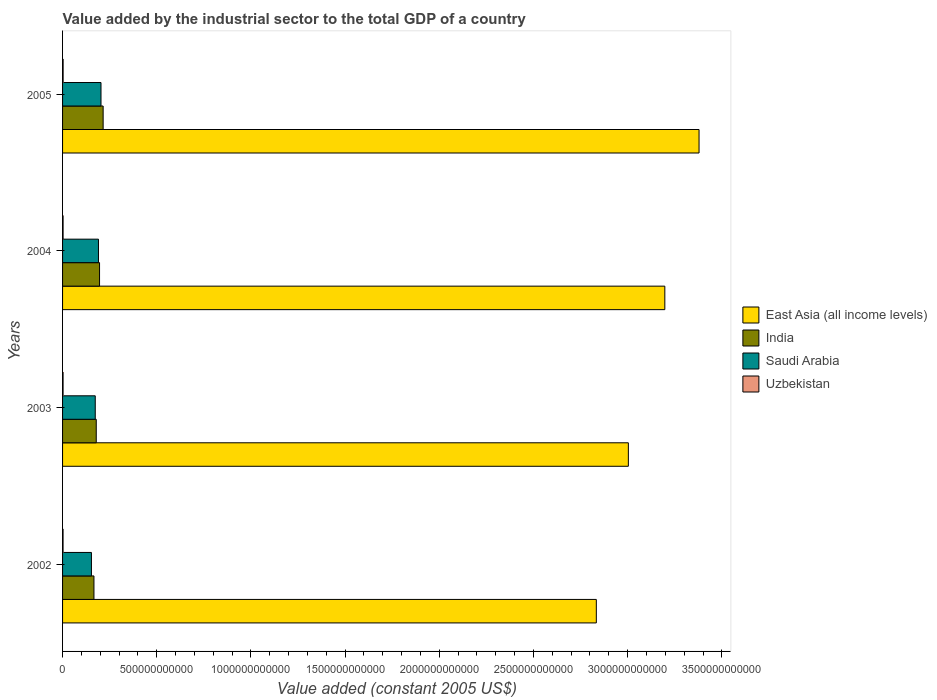Are the number of bars on each tick of the Y-axis equal?
Your answer should be compact. Yes. How many bars are there on the 3rd tick from the top?
Your answer should be very brief. 4. How many bars are there on the 3rd tick from the bottom?
Offer a terse response. 4. What is the value added by the industrial sector in India in 2004?
Provide a short and direct response. 1.96e+11. Across all years, what is the maximum value added by the industrial sector in India?
Give a very brief answer. 2.15e+11. Across all years, what is the minimum value added by the industrial sector in Saudi Arabia?
Make the answer very short. 1.53e+11. In which year was the value added by the industrial sector in Saudi Arabia maximum?
Keep it short and to the point. 2005. What is the total value added by the industrial sector in India in the graph?
Make the answer very short. 7.57e+11. What is the difference between the value added by the industrial sector in India in 2004 and that in 2005?
Your answer should be compact. -1.91e+1. What is the difference between the value added by the industrial sector in India in 2005 and the value added by the industrial sector in Uzbekistan in 2002?
Make the answer very short. 2.13e+11. What is the average value added by the industrial sector in Saudi Arabia per year?
Provide a succinct answer. 1.80e+11. In the year 2003, what is the difference between the value added by the industrial sector in India and value added by the industrial sector in East Asia (all income levels)?
Provide a succinct answer. -2.82e+12. What is the ratio of the value added by the industrial sector in Uzbekistan in 2003 to that in 2004?
Provide a short and direct response. 0.95. Is the value added by the industrial sector in Saudi Arabia in 2002 less than that in 2005?
Your answer should be compact. Yes. Is the difference between the value added by the industrial sector in India in 2002 and 2004 greater than the difference between the value added by the industrial sector in East Asia (all income levels) in 2002 and 2004?
Make the answer very short. Yes. What is the difference between the highest and the second highest value added by the industrial sector in Uzbekistan?
Your response must be concise. 1.40e+08. What is the difference between the highest and the lowest value added by the industrial sector in Saudi Arabia?
Keep it short and to the point. 5.07e+1. In how many years, is the value added by the industrial sector in India greater than the average value added by the industrial sector in India taken over all years?
Provide a succinct answer. 2. Is the sum of the value added by the industrial sector in Saudi Arabia in 2003 and 2005 greater than the maximum value added by the industrial sector in India across all years?
Your answer should be compact. Yes. Is it the case that in every year, the sum of the value added by the industrial sector in India and value added by the industrial sector in East Asia (all income levels) is greater than the sum of value added by the industrial sector in Saudi Arabia and value added by the industrial sector in Uzbekistan?
Ensure brevity in your answer.  No. What does the 4th bar from the top in 2004 represents?
Your response must be concise. East Asia (all income levels). What does the 2nd bar from the bottom in 2003 represents?
Your answer should be very brief. India. Are all the bars in the graph horizontal?
Offer a terse response. Yes. How many years are there in the graph?
Provide a succinct answer. 4. What is the difference between two consecutive major ticks on the X-axis?
Your answer should be compact. 5.00e+11. Are the values on the major ticks of X-axis written in scientific E-notation?
Give a very brief answer. No. Does the graph contain any zero values?
Give a very brief answer. No. Where does the legend appear in the graph?
Provide a short and direct response. Center right. What is the title of the graph?
Make the answer very short. Value added by the industrial sector to the total GDP of a country. What is the label or title of the X-axis?
Offer a terse response. Value added (constant 2005 US$). What is the label or title of the Y-axis?
Offer a very short reply. Years. What is the Value added (constant 2005 US$) of East Asia (all income levels) in 2002?
Your response must be concise. 2.83e+12. What is the Value added (constant 2005 US$) in India in 2002?
Make the answer very short. 1.67e+11. What is the Value added (constant 2005 US$) in Saudi Arabia in 2002?
Your answer should be compact. 1.53e+11. What is the Value added (constant 2005 US$) in Uzbekistan in 2002?
Offer a very short reply. 2.60e+09. What is the Value added (constant 2005 US$) in East Asia (all income levels) in 2003?
Ensure brevity in your answer.  3.00e+12. What is the Value added (constant 2005 US$) of India in 2003?
Provide a succinct answer. 1.79e+11. What is the Value added (constant 2005 US$) in Saudi Arabia in 2003?
Your answer should be compact. 1.74e+11. What is the Value added (constant 2005 US$) of Uzbekistan in 2003?
Keep it short and to the point. 2.69e+09. What is the Value added (constant 2005 US$) in East Asia (all income levels) in 2004?
Ensure brevity in your answer.  3.20e+12. What is the Value added (constant 2005 US$) of India in 2004?
Provide a succinct answer. 1.96e+11. What is the Value added (constant 2005 US$) of Saudi Arabia in 2004?
Give a very brief answer. 1.91e+11. What is the Value added (constant 2005 US$) in Uzbekistan in 2004?
Offer a terse response. 2.82e+09. What is the Value added (constant 2005 US$) in East Asia (all income levels) in 2005?
Offer a very short reply. 3.38e+12. What is the Value added (constant 2005 US$) of India in 2005?
Provide a succinct answer. 2.15e+11. What is the Value added (constant 2005 US$) of Saudi Arabia in 2005?
Your answer should be very brief. 2.04e+11. What is the Value added (constant 2005 US$) in Uzbekistan in 2005?
Provide a succinct answer. 2.96e+09. Across all years, what is the maximum Value added (constant 2005 US$) in East Asia (all income levels)?
Your answer should be compact. 3.38e+12. Across all years, what is the maximum Value added (constant 2005 US$) in India?
Your answer should be very brief. 2.15e+11. Across all years, what is the maximum Value added (constant 2005 US$) in Saudi Arabia?
Give a very brief answer. 2.04e+11. Across all years, what is the maximum Value added (constant 2005 US$) in Uzbekistan?
Your answer should be compact. 2.96e+09. Across all years, what is the minimum Value added (constant 2005 US$) of East Asia (all income levels)?
Give a very brief answer. 2.83e+12. Across all years, what is the minimum Value added (constant 2005 US$) of India?
Your answer should be very brief. 1.67e+11. Across all years, what is the minimum Value added (constant 2005 US$) in Saudi Arabia?
Keep it short and to the point. 1.53e+11. Across all years, what is the minimum Value added (constant 2005 US$) in Uzbekistan?
Provide a short and direct response. 2.60e+09. What is the total Value added (constant 2005 US$) in East Asia (all income levels) in the graph?
Provide a short and direct response. 1.24e+13. What is the total Value added (constant 2005 US$) in India in the graph?
Offer a very short reply. 7.57e+11. What is the total Value added (constant 2005 US$) of Saudi Arabia in the graph?
Offer a terse response. 7.21e+11. What is the total Value added (constant 2005 US$) in Uzbekistan in the graph?
Your answer should be compact. 1.11e+1. What is the difference between the Value added (constant 2005 US$) in East Asia (all income levels) in 2002 and that in 2003?
Ensure brevity in your answer.  -1.70e+11. What is the difference between the Value added (constant 2005 US$) in India in 2002 and that in 2003?
Provide a short and direct response. -1.22e+1. What is the difference between the Value added (constant 2005 US$) of Saudi Arabia in 2002 and that in 2003?
Ensure brevity in your answer.  -2.03e+1. What is the difference between the Value added (constant 2005 US$) of Uzbekistan in 2002 and that in 2003?
Make the answer very short. -8.27e+07. What is the difference between the Value added (constant 2005 US$) of East Asia (all income levels) in 2002 and that in 2004?
Keep it short and to the point. -3.64e+11. What is the difference between the Value added (constant 2005 US$) in India in 2002 and that in 2004?
Offer a terse response. -2.97e+1. What is the difference between the Value added (constant 2005 US$) in Saudi Arabia in 2002 and that in 2004?
Your answer should be very brief. -3.73e+1. What is the difference between the Value added (constant 2005 US$) in Uzbekistan in 2002 and that in 2004?
Offer a very short reply. -2.17e+08. What is the difference between the Value added (constant 2005 US$) of East Asia (all income levels) in 2002 and that in 2005?
Keep it short and to the point. -5.45e+11. What is the difference between the Value added (constant 2005 US$) of India in 2002 and that in 2005?
Make the answer very short. -4.88e+1. What is the difference between the Value added (constant 2005 US$) in Saudi Arabia in 2002 and that in 2005?
Offer a terse response. -5.07e+1. What is the difference between the Value added (constant 2005 US$) of Uzbekistan in 2002 and that in 2005?
Offer a very short reply. -3.57e+08. What is the difference between the Value added (constant 2005 US$) of East Asia (all income levels) in 2003 and that in 2004?
Provide a short and direct response. -1.94e+11. What is the difference between the Value added (constant 2005 US$) in India in 2003 and that in 2004?
Provide a short and direct response. -1.75e+1. What is the difference between the Value added (constant 2005 US$) of Saudi Arabia in 2003 and that in 2004?
Your answer should be compact. -1.70e+1. What is the difference between the Value added (constant 2005 US$) of Uzbekistan in 2003 and that in 2004?
Provide a succinct answer. -1.34e+08. What is the difference between the Value added (constant 2005 US$) of East Asia (all income levels) in 2003 and that in 2005?
Provide a short and direct response. -3.75e+11. What is the difference between the Value added (constant 2005 US$) in India in 2003 and that in 2005?
Ensure brevity in your answer.  -3.66e+1. What is the difference between the Value added (constant 2005 US$) in Saudi Arabia in 2003 and that in 2005?
Your answer should be compact. -3.05e+1. What is the difference between the Value added (constant 2005 US$) of Uzbekistan in 2003 and that in 2005?
Your answer should be compact. -2.75e+08. What is the difference between the Value added (constant 2005 US$) of East Asia (all income levels) in 2004 and that in 2005?
Offer a terse response. -1.82e+11. What is the difference between the Value added (constant 2005 US$) of India in 2004 and that in 2005?
Offer a very short reply. -1.91e+1. What is the difference between the Value added (constant 2005 US$) of Saudi Arabia in 2004 and that in 2005?
Your response must be concise. -1.34e+1. What is the difference between the Value added (constant 2005 US$) of Uzbekistan in 2004 and that in 2005?
Your answer should be compact. -1.40e+08. What is the difference between the Value added (constant 2005 US$) of East Asia (all income levels) in 2002 and the Value added (constant 2005 US$) of India in 2003?
Offer a terse response. 2.65e+12. What is the difference between the Value added (constant 2005 US$) of East Asia (all income levels) in 2002 and the Value added (constant 2005 US$) of Saudi Arabia in 2003?
Make the answer very short. 2.66e+12. What is the difference between the Value added (constant 2005 US$) of East Asia (all income levels) in 2002 and the Value added (constant 2005 US$) of Uzbekistan in 2003?
Offer a very short reply. 2.83e+12. What is the difference between the Value added (constant 2005 US$) in India in 2002 and the Value added (constant 2005 US$) in Saudi Arabia in 2003?
Offer a terse response. -6.93e+09. What is the difference between the Value added (constant 2005 US$) in India in 2002 and the Value added (constant 2005 US$) in Uzbekistan in 2003?
Keep it short and to the point. 1.64e+11. What is the difference between the Value added (constant 2005 US$) of Saudi Arabia in 2002 and the Value added (constant 2005 US$) of Uzbekistan in 2003?
Keep it short and to the point. 1.51e+11. What is the difference between the Value added (constant 2005 US$) of East Asia (all income levels) in 2002 and the Value added (constant 2005 US$) of India in 2004?
Offer a very short reply. 2.64e+12. What is the difference between the Value added (constant 2005 US$) of East Asia (all income levels) in 2002 and the Value added (constant 2005 US$) of Saudi Arabia in 2004?
Offer a very short reply. 2.64e+12. What is the difference between the Value added (constant 2005 US$) of East Asia (all income levels) in 2002 and the Value added (constant 2005 US$) of Uzbekistan in 2004?
Your response must be concise. 2.83e+12. What is the difference between the Value added (constant 2005 US$) of India in 2002 and the Value added (constant 2005 US$) of Saudi Arabia in 2004?
Ensure brevity in your answer.  -2.39e+1. What is the difference between the Value added (constant 2005 US$) of India in 2002 and the Value added (constant 2005 US$) of Uzbekistan in 2004?
Keep it short and to the point. 1.64e+11. What is the difference between the Value added (constant 2005 US$) in Saudi Arabia in 2002 and the Value added (constant 2005 US$) in Uzbekistan in 2004?
Provide a succinct answer. 1.50e+11. What is the difference between the Value added (constant 2005 US$) of East Asia (all income levels) in 2002 and the Value added (constant 2005 US$) of India in 2005?
Provide a short and direct response. 2.62e+12. What is the difference between the Value added (constant 2005 US$) in East Asia (all income levels) in 2002 and the Value added (constant 2005 US$) in Saudi Arabia in 2005?
Make the answer very short. 2.63e+12. What is the difference between the Value added (constant 2005 US$) in East Asia (all income levels) in 2002 and the Value added (constant 2005 US$) in Uzbekistan in 2005?
Your answer should be compact. 2.83e+12. What is the difference between the Value added (constant 2005 US$) in India in 2002 and the Value added (constant 2005 US$) in Saudi Arabia in 2005?
Keep it short and to the point. -3.74e+1. What is the difference between the Value added (constant 2005 US$) in India in 2002 and the Value added (constant 2005 US$) in Uzbekistan in 2005?
Your answer should be very brief. 1.64e+11. What is the difference between the Value added (constant 2005 US$) of Saudi Arabia in 2002 and the Value added (constant 2005 US$) of Uzbekistan in 2005?
Offer a terse response. 1.50e+11. What is the difference between the Value added (constant 2005 US$) in East Asia (all income levels) in 2003 and the Value added (constant 2005 US$) in India in 2004?
Make the answer very short. 2.81e+12. What is the difference between the Value added (constant 2005 US$) in East Asia (all income levels) in 2003 and the Value added (constant 2005 US$) in Saudi Arabia in 2004?
Your response must be concise. 2.81e+12. What is the difference between the Value added (constant 2005 US$) of East Asia (all income levels) in 2003 and the Value added (constant 2005 US$) of Uzbekistan in 2004?
Keep it short and to the point. 3.00e+12. What is the difference between the Value added (constant 2005 US$) in India in 2003 and the Value added (constant 2005 US$) in Saudi Arabia in 2004?
Your answer should be compact. -1.18e+1. What is the difference between the Value added (constant 2005 US$) of India in 2003 and the Value added (constant 2005 US$) of Uzbekistan in 2004?
Your answer should be very brief. 1.76e+11. What is the difference between the Value added (constant 2005 US$) in Saudi Arabia in 2003 and the Value added (constant 2005 US$) in Uzbekistan in 2004?
Provide a succinct answer. 1.71e+11. What is the difference between the Value added (constant 2005 US$) of East Asia (all income levels) in 2003 and the Value added (constant 2005 US$) of India in 2005?
Offer a very short reply. 2.79e+12. What is the difference between the Value added (constant 2005 US$) in East Asia (all income levels) in 2003 and the Value added (constant 2005 US$) in Saudi Arabia in 2005?
Your answer should be very brief. 2.80e+12. What is the difference between the Value added (constant 2005 US$) in East Asia (all income levels) in 2003 and the Value added (constant 2005 US$) in Uzbekistan in 2005?
Offer a terse response. 3.00e+12. What is the difference between the Value added (constant 2005 US$) of India in 2003 and the Value added (constant 2005 US$) of Saudi Arabia in 2005?
Give a very brief answer. -2.52e+1. What is the difference between the Value added (constant 2005 US$) in India in 2003 and the Value added (constant 2005 US$) in Uzbekistan in 2005?
Your response must be concise. 1.76e+11. What is the difference between the Value added (constant 2005 US$) of Saudi Arabia in 2003 and the Value added (constant 2005 US$) of Uzbekistan in 2005?
Make the answer very short. 1.71e+11. What is the difference between the Value added (constant 2005 US$) of East Asia (all income levels) in 2004 and the Value added (constant 2005 US$) of India in 2005?
Your answer should be compact. 2.98e+12. What is the difference between the Value added (constant 2005 US$) in East Asia (all income levels) in 2004 and the Value added (constant 2005 US$) in Saudi Arabia in 2005?
Provide a succinct answer. 2.99e+12. What is the difference between the Value added (constant 2005 US$) in East Asia (all income levels) in 2004 and the Value added (constant 2005 US$) in Uzbekistan in 2005?
Ensure brevity in your answer.  3.19e+12. What is the difference between the Value added (constant 2005 US$) in India in 2004 and the Value added (constant 2005 US$) in Saudi Arabia in 2005?
Your answer should be very brief. -7.65e+09. What is the difference between the Value added (constant 2005 US$) of India in 2004 and the Value added (constant 2005 US$) of Uzbekistan in 2005?
Offer a very short reply. 1.93e+11. What is the difference between the Value added (constant 2005 US$) in Saudi Arabia in 2004 and the Value added (constant 2005 US$) in Uzbekistan in 2005?
Give a very brief answer. 1.88e+11. What is the average Value added (constant 2005 US$) in East Asia (all income levels) per year?
Offer a terse response. 3.10e+12. What is the average Value added (constant 2005 US$) of India per year?
Ensure brevity in your answer.  1.89e+11. What is the average Value added (constant 2005 US$) of Saudi Arabia per year?
Keep it short and to the point. 1.80e+11. What is the average Value added (constant 2005 US$) of Uzbekistan per year?
Ensure brevity in your answer.  2.77e+09. In the year 2002, what is the difference between the Value added (constant 2005 US$) of East Asia (all income levels) and Value added (constant 2005 US$) of India?
Make the answer very short. 2.67e+12. In the year 2002, what is the difference between the Value added (constant 2005 US$) of East Asia (all income levels) and Value added (constant 2005 US$) of Saudi Arabia?
Provide a short and direct response. 2.68e+12. In the year 2002, what is the difference between the Value added (constant 2005 US$) in East Asia (all income levels) and Value added (constant 2005 US$) in Uzbekistan?
Keep it short and to the point. 2.83e+12. In the year 2002, what is the difference between the Value added (constant 2005 US$) in India and Value added (constant 2005 US$) in Saudi Arabia?
Give a very brief answer. 1.33e+1. In the year 2002, what is the difference between the Value added (constant 2005 US$) in India and Value added (constant 2005 US$) in Uzbekistan?
Your answer should be compact. 1.64e+11. In the year 2002, what is the difference between the Value added (constant 2005 US$) of Saudi Arabia and Value added (constant 2005 US$) of Uzbekistan?
Keep it short and to the point. 1.51e+11. In the year 2003, what is the difference between the Value added (constant 2005 US$) of East Asia (all income levels) and Value added (constant 2005 US$) of India?
Make the answer very short. 2.82e+12. In the year 2003, what is the difference between the Value added (constant 2005 US$) of East Asia (all income levels) and Value added (constant 2005 US$) of Saudi Arabia?
Your response must be concise. 2.83e+12. In the year 2003, what is the difference between the Value added (constant 2005 US$) of East Asia (all income levels) and Value added (constant 2005 US$) of Uzbekistan?
Your answer should be very brief. 3.00e+12. In the year 2003, what is the difference between the Value added (constant 2005 US$) of India and Value added (constant 2005 US$) of Saudi Arabia?
Give a very brief answer. 5.27e+09. In the year 2003, what is the difference between the Value added (constant 2005 US$) in India and Value added (constant 2005 US$) in Uzbekistan?
Offer a terse response. 1.76e+11. In the year 2003, what is the difference between the Value added (constant 2005 US$) in Saudi Arabia and Value added (constant 2005 US$) in Uzbekistan?
Offer a very short reply. 1.71e+11. In the year 2004, what is the difference between the Value added (constant 2005 US$) of East Asia (all income levels) and Value added (constant 2005 US$) of India?
Offer a terse response. 3.00e+12. In the year 2004, what is the difference between the Value added (constant 2005 US$) in East Asia (all income levels) and Value added (constant 2005 US$) in Saudi Arabia?
Make the answer very short. 3.01e+12. In the year 2004, what is the difference between the Value added (constant 2005 US$) of East Asia (all income levels) and Value added (constant 2005 US$) of Uzbekistan?
Offer a terse response. 3.19e+12. In the year 2004, what is the difference between the Value added (constant 2005 US$) in India and Value added (constant 2005 US$) in Saudi Arabia?
Ensure brevity in your answer.  5.80e+09. In the year 2004, what is the difference between the Value added (constant 2005 US$) of India and Value added (constant 2005 US$) of Uzbekistan?
Give a very brief answer. 1.94e+11. In the year 2004, what is the difference between the Value added (constant 2005 US$) of Saudi Arabia and Value added (constant 2005 US$) of Uzbekistan?
Your answer should be compact. 1.88e+11. In the year 2005, what is the difference between the Value added (constant 2005 US$) of East Asia (all income levels) and Value added (constant 2005 US$) of India?
Offer a terse response. 3.16e+12. In the year 2005, what is the difference between the Value added (constant 2005 US$) in East Asia (all income levels) and Value added (constant 2005 US$) in Saudi Arabia?
Your response must be concise. 3.17e+12. In the year 2005, what is the difference between the Value added (constant 2005 US$) in East Asia (all income levels) and Value added (constant 2005 US$) in Uzbekistan?
Make the answer very short. 3.38e+12. In the year 2005, what is the difference between the Value added (constant 2005 US$) of India and Value added (constant 2005 US$) of Saudi Arabia?
Give a very brief answer. 1.14e+1. In the year 2005, what is the difference between the Value added (constant 2005 US$) of India and Value added (constant 2005 US$) of Uzbekistan?
Provide a succinct answer. 2.12e+11. In the year 2005, what is the difference between the Value added (constant 2005 US$) in Saudi Arabia and Value added (constant 2005 US$) in Uzbekistan?
Provide a succinct answer. 2.01e+11. What is the ratio of the Value added (constant 2005 US$) in East Asia (all income levels) in 2002 to that in 2003?
Offer a terse response. 0.94. What is the ratio of the Value added (constant 2005 US$) in India in 2002 to that in 2003?
Your response must be concise. 0.93. What is the ratio of the Value added (constant 2005 US$) in Saudi Arabia in 2002 to that in 2003?
Your answer should be very brief. 0.88. What is the ratio of the Value added (constant 2005 US$) in Uzbekistan in 2002 to that in 2003?
Offer a terse response. 0.97. What is the ratio of the Value added (constant 2005 US$) in East Asia (all income levels) in 2002 to that in 2004?
Your answer should be very brief. 0.89. What is the ratio of the Value added (constant 2005 US$) of India in 2002 to that in 2004?
Give a very brief answer. 0.85. What is the ratio of the Value added (constant 2005 US$) in Saudi Arabia in 2002 to that in 2004?
Provide a short and direct response. 0.8. What is the ratio of the Value added (constant 2005 US$) in Uzbekistan in 2002 to that in 2004?
Provide a short and direct response. 0.92. What is the ratio of the Value added (constant 2005 US$) in East Asia (all income levels) in 2002 to that in 2005?
Your answer should be very brief. 0.84. What is the ratio of the Value added (constant 2005 US$) in India in 2002 to that in 2005?
Keep it short and to the point. 0.77. What is the ratio of the Value added (constant 2005 US$) in Saudi Arabia in 2002 to that in 2005?
Provide a succinct answer. 0.75. What is the ratio of the Value added (constant 2005 US$) in Uzbekistan in 2002 to that in 2005?
Your answer should be very brief. 0.88. What is the ratio of the Value added (constant 2005 US$) in East Asia (all income levels) in 2003 to that in 2004?
Ensure brevity in your answer.  0.94. What is the ratio of the Value added (constant 2005 US$) in India in 2003 to that in 2004?
Make the answer very short. 0.91. What is the ratio of the Value added (constant 2005 US$) in Saudi Arabia in 2003 to that in 2004?
Your answer should be compact. 0.91. What is the ratio of the Value added (constant 2005 US$) of Uzbekistan in 2003 to that in 2004?
Your answer should be very brief. 0.95. What is the ratio of the Value added (constant 2005 US$) in India in 2003 to that in 2005?
Your answer should be compact. 0.83. What is the ratio of the Value added (constant 2005 US$) in Saudi Arabia in 2003 to that in 2005?
Your response must be concise. 0.85. What is the ratio of the Value added (constant 2005 US$) of Uzbekistan in 2003 to that in 2005?
Your answer should be compact. 0.91. What is the ratio of the Value added (constant 2005 US$) of East Asia (all income levels) in 2004 to that in 2005?
Provide a succinct answer. 0.95. What is the ratio of the Value added (constant 2005 US$) of India in 2004 to that in 2005?
Provide a succinct answer. 0.91. What is the ratio of the Value added (constant 2005 US$) of Saudi Arabia in 2004 to that in 2005?
Your answer should be compact. 0.93. What is the ratio of the Value added (constant 2005 US$) of Uzbekistan in 2004 to that in 2005?
Ensure brevity in your answer.  0.95. What is the difference between the highest and the second highest Value added (constant 2005 US$) in East Asia (all income levels)?
Ensure brevity in your answer.  1.82e+11. What is the difference between the highest and the second highest Value added (constant 2005 US$) of India?
Offer a very short reply. 1.91e+1. What is the difference between the highest and the second highest Value added (constant 2005 US$) in Saudi Arabia?
Your answer should be compact. 1.34e+1. What is the difference between the highest and the second highest Value added (constant 2005 US$) of Uzbekistan?
Keep it short and to the point. 1.40e+08. What is the difference between the highest and the lowest Value added (constant 2005 US$) in East Asia (all income levels)?
Offer a very short reply. 5.45e+11. What is the difference between the highest and the lowest Value added (constant 2005 US$) of India?
Give a very brief answer. 4.88e+1. What is the difference between the highest and the lowest Value added (constant 2005 US$) of Saudi Arabia?
Provide a succinct answer. 5.07e+1. What is the difference between the highest and the lowest Value added (constant 2005 US$) in Uzbekistan?
Ensure brevity in your answer.  3.57e+08. 